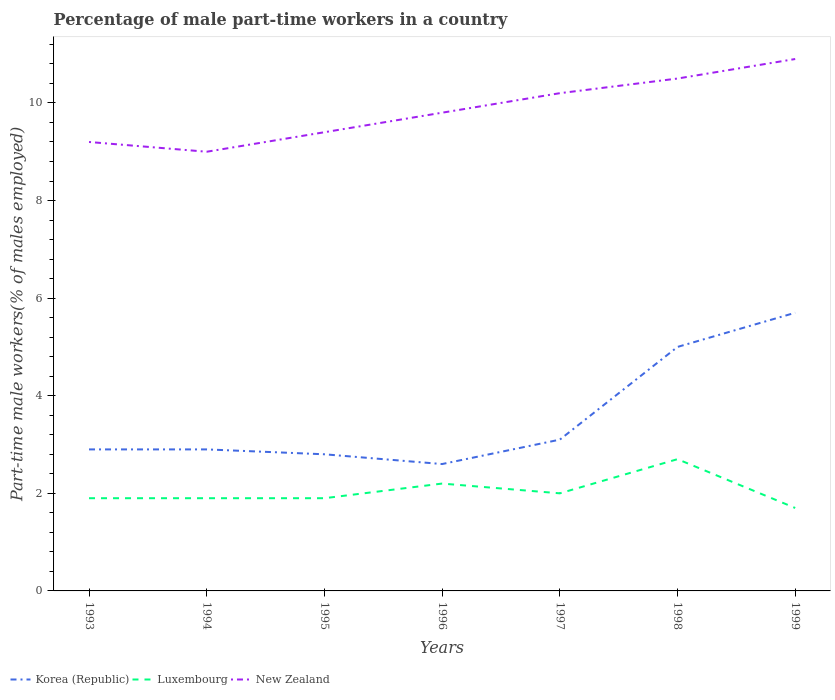Across all years, what is the maximum percentage of male part-time workers in Luxembourg?
Provide a short and direct response. 1.7. In which year was the percentage of male part-time workers in Luxembourg maximum?
Provide a succinct answer. 1999. What is the total percentage of male part-time workers in Luxembourg in the graph?
Offer a terse response. -0.3. What is the difference between the highest and the second highest percentage of male part-time workers in New Zealand?
Make the answer very short. 1.9. What is the difference between the highest and the lowest percentage of male part-time workers in Korea (Republic)?
Provide a short and direct response. 2. How many lines are there?
Provide a succinct answer. 3. How many years are there in the graph?
Give a very brief answer. 7. Are the values on the major ticks of Y-axis written in scientific E-notation?
Ensure brevity in your answer.  No. Does the graph contain any zero values?
Provide a succinct answer. No. Does the graph contain grids?
Offer a terse response. No. Where does the legend appear in the graph?
Your answer should be compact. Bottom left. How many legend labels are there?
Ensure brevity in your answer.  3. What is the title of the graph?
Keep it short and to the point. Percentage of male part-time workers in a country. Does "Guyana" appear as one of the legend labels in the graph?
Give a very brief answer. No. What is the label or title of the Y-axis?
Your response must be concise. Part-time male workers(% of males employed). What is the Part-time male workers(% of males employed) of Korea (Republic) in 1993?
Your answer should be compact. 2.9. What is the Part-time male workers(% of males employed) in Luxembourg in 1993?
Give a very brief answer. 1.9. What is the Part-time male workers(% of males employed) in New Zealand in 1993?
Provide a succinct answer. 9.2. What is the Part-time male workers(% of males employed) of Korea (Republic) in 1994?
Your response must be concise. 2.9. What is the Part-time male workers(% of males employed) in Luxembourg in 1994?
Offer a very short reply. 1.9. What is the Part-time male workers(% of males employed) in New Zealand in 1994?
Ensure brevity in your answer.  9. What is the Part-time male workers(% of males employed) in Korea (Republic) in 1995?
Provide a succinct answer. 2.8. What is the Part-time male workers(% of males employed) of Luxembourg in 1995?
Keep it short and to the point. 1.9. What is the Part-time male workers(% of males employed) of New Zealand in 1995?
Your answer should be very brief. 9.4. What is the Part-time male workers(% of males employed) in Korea (Republic) in 1996?
Your answer should be compact. 2.6. What is the Part-time male workers(% of males employed) in Luxembourg in 1996?
Keep it short and to the point. 2.2. What is the Part-time male workers(% of males employed) in New Zealand in 1996?
Provide a short and direct response. 9.8. What is the Part-time male workers(% of males employed) of Korea (Republic) in 1997?
Your response must be concise. 3.1. What is the Part-time male workers(% of males employed) in Luxembourg in 1997?
Make the answer very short. 2. What is the Part-time male workers(% of males employed) in New Zealand in 1997?
Make the answer very short. 10.2. What is the Part-time male workers(% of males employed) of Korea (Republic) in 1998?
Offer a very short reply. 5. What is the Part-time male workers(% of males employed) of Luxembourg in 1998?
Provide a succinct answer. 2.7. What is the Part-time male workers(% of males employed) in Korea (Republic) in 1999?
Your answer should be compact. 5.7. What is the Part-time male workers(% of males employed) of Luxembourg in 1999?
Keep it short and to the point. 1.7. What is the Part-time male workers(% of males employed) in New Zealand in 1999?
Make the answer very short. 10.9. Across all years, what is the maximum Part-time male workers(% of males employed) of Korea (Republic)?
Make the answer very short. 5.7. Across all years, what is the maximum Part-time male workers(% of males employed) in Luxembourg?
Offer a very short reply. 2.7. Across all years, what is the maximum Part-time male workers(% of males employed) in New Zealand?
Your answer should be compact. 10.9. Across all years, what is the minimum Part-time male workers(% of males employed) of Korea (Republic)?
Your answer should be very brief. 2.6. Across all years, what is the minimum Part-time male workers(% of males employed) of Luxembourg?
Provide a succinct answer. 1.7. Across all years, what is the minimum Part-time male workers(% of males employed) in New Zealand?
Give a very brief answer. 9. What is the total Part-time male workers(% of males employed) of Korea (Republic) in the graph?
Make the answer very short. 25. What is the total Part-time male workers(% of males employed) of New Zealand in the graph?
Offer a terse response. 69. What is the difference between the Part-time male workers(% of males employed) of Korea (Republic) in 1993 and that in 1994?
Your response must be concise. 0. What is the difference between the Part-time male workers(% of males employed) of Korea (Republic) in 1993 and that in 1995?
Give a very brief answer. 0.1. What is the difference between the Part-time male workers(% of males employed) in New Zealand in 1993 and that in 1995?
Keep it short and to the point. -0.2. What is the difference between the Part-time male workers(% of males employed) in Korea (Republic) in 1993 and that in 1996?
Provide a short and direct response. 0.3. What is the difference between the Part-time male workers(% of males employed) of New Zealand in 1993 and that in 1996?
Provide a succinct answer. -0.6. What is the difference between the Part-time male workers(% of males employed) in Korea (Republic) in 1993 and that in 1997?
Provide a short and direct response. -0.2. What is the difference between the Part-time male workers(% of males employed) of Luxembourg in 1993 and that in 1997?
Your answer should be compact. -0.1. What is the difference between the Part-time male workers(% of males employed) of New Zealand in 1993 and that in 1998?
Your answer should be very brief. -1.3. What is the difference between the Part-time male workers(% of males employed) in Korea (Republic) in 1993 and that in 1999?
Give a very brief answer. -2.8. What is the difference between the Part-time male workers(% of males employed) in Luxembourg in 1993 and that in 1999?
Give a very brief answer. 0.2. What is the difference between the Part-time male workers(% of males employed) of New Zealand in 1993 and that in 1999?
Give a very brief answer. -1.7. What is the difference between the Part-time male workers(% of males employed) in New Zealand in 1994 and that in 1995?
Make the answer very short. -0.4. What is the difference between the Part-time male workers(% of males employed) of Korea (Republic) in 1994 and that in 1996?
Provide a short and direct response. 0.3. What is the difference between the Part-time male workers(% of males employed) of Luxembourg in 1994 and that in 1996?
Your response must be concise. -0.3. What is the difference between the Part-time male workers(% of males employed) of New Zealand in 1994 and that in 1996?
Offer a terse response. -0.8. What is the difference between the Part-time male workers(% of males employed) of Korea (Republic) in 1994 and that in 1997?
Ensure brevity in your answer.  -0.2. What is the difference between the Part-time male workers(% of males employed) of Korea (Republic) in 1994 and that in 1998?
Your answer should be very brief. -2.1. What is the difference between the Part-time male workers(% of males employed) of New Zealand in 1994 and that in 1998?
Give a very brief answer. -1.5. What is the difference between the Part-time male workers(% of males employed) of Korea (Republic) in 1994 and that in 1999?
Your answer should be compact. -2.8. What is the difference between the Part-time male workers(% of males employed) of New Zealand in 1995 and that in 1996?
Offer a very short reply. -0.4. What is the difference between the Part-time male workers(% of males employed) in Luxembourg in 1995 and that in 1997?
Ensure brevity in your answer.  -0.1. What is the difference between the Part-time male workers(% of males employed) in Korea (Republic) in 1995 and that in 1998?
Give a very brief answer. -2.2. What is the difference between the Part-time male workers(% of males employed) in Luxembourg in 1995 and that in 1998?
Keep it short and to the point. -0.8. What is the difference between the Part-time male workers(% of males employed) of Korea (Republic) in 1995 and that in 1999?
Your answer should be compact. -2.9. What is the difference between the Part-time male workers(% of males employed) in New Zealand in 1996 and that in 1997?
Your response must be concise. -0.4. What is the difference between the Part-time male workers(% of males employed) in Korea (Republic) in 1996 and that in 1998?
Provide a short and direct response. -2.4. What is the difference between the Part-time male workers(% of males employed) of New Zealand in 1996 and that in 1998?
Your response must be concise. -0.7. What is the difference between the Part-time male workers(% of males employed) in Luxembourg in 1996 and that in 1999?
Provide a succinct answer. 0.5. What is the difference between the Part-time male workers(% of males employed) of Korea (Republic) in 1997 and that in 1998?
Your answer should be compact. -1.9. What is the difference between the Part-time male workers(% of males employed) of Luxembourg in 1997 and that in 1998?
Give a very brief answer. -0.7. What is the difference between the Part-time male workers(% of males employed) of New Zealand in 1997 and that in 1998?
Keep it short and to the point. -0.3. What is the difference between the Part-time male workers(% of males employed) in Luxembourg in 1997 and that in 1999?
Offer a terse response. 0.3. What is the difference between the Part-time male workers(% of males employed) of Korea (Republic) in 1998 and that in 1999?
Offer a very short reply. -0.7. What is the difference between the Part-time male workers(% of males employed) in Luxembourg in 1998 and that in 1999?
Provide a succinct answer. 1. What is the difference between the Part-time male workers(% of males employed) in Korea (Republic) in 1993 and the Part-time male workers(% of males employed) in New Zealand in 1994?
Your answer should be compact. -6.1. What is the difference between the Part-time male workers(% of males employed) of Korea (Republic) in 1993 and the Part-time male workers(% of males employed) of Luxembourg in 1996?
Your answer should be compact. 0.7. What is the difference between the Part-time male workers(% of males employed) in Luxembourg in 1993 and the Part-time male workers(% of males employed) in New Zealand in 1996?
Keep it short and to the point. -7.9. What is the difference between the Part-time male workers(% of males employed) in Luxembourg in 1993 and the Part-time male workers(% of males employed) in New Zealand in 1997?
Keep it short and to the point. -8.3. What is the difference between the Part-time male workers(% of males employed) of Korea (Republic) in 1993 and the Part-time male workers(% of males employed) of New Zealand in 1998?
Offer a very short reply. -7.6. What is the difference between the Part-time male workers(% of males employed) of Luxembourg in 1993 and the Part-time male workers(% of males employed) of New Zealand in 1998?
Your answer should be compact. -8.6. What is the difference between the Part-time male workers(% of males employed) in Korea (Republic) in 1993 and the Part-time male workers(% of males employed) in Luxembourg in 1999?
Your answer should be compact. 1.2. What is the difference between the Part-time male workers(% of males employed) in Korea (Republic) in 1993 and the Part-time male workers(% of males employed) in New Zealand in 1999?
Your response must be concise. -8. What is the difference between the Part-time male workers(% of males employed) in Luxembourg in 1993 and the Part-time male workers(% of males employed) in New Zealand in 1999?
Your answer should be compact. -9. What is the difference between the Part-time male workers(% of males employed) of Korea (Republic) in 1994 and the Part-time male workers(% of males employed) of New Zealand in 1995?
Provide a short and direct response. -6.5. What is the difference between the Part-time male workers(% of males employed) in Luxembourg in 1994 and the Part-time male workers(% of males employed) in New Zealand in 1995?
Make the answer very short. -7.5. What is the difference between the Part-time male workers(% of males employed) of Korea (Republic) in 1994 and the Part-time male workers(% of males employed) of Luxembourg in 1996?
Your answer should be compact. 0.7. What is the difference between the Part-time male workers(% of males employed) in Korea (Republic) in 1994 and the Part-time male workers(% of males employed) in New Zealand in 1996?
Give a very brief answer. -6.9. What is the difference between the Part-time male workers(% of males employed) in Luxembourg in 1994 and the Part-time male workers(% of males employed) in New Zealand in 1996?
Provide a succinct answer. -7.9. What is the difference between the Part-time male workers(% of males employed) of Luxembourg in 1994 and the Part-time male workers(% of males employed) of New Zealand in 1997?
Make the answer very short. -8.3. What is the difference between the Part-time male workers(% of males employed) in Korea (Republic) in 1994 and the Part-time male workers(% of males employed) in Luxembourg in 1998?
Your answer should be very brief. 0.2. What is the difference between the Part-time male workers(% of males employed) in Korea (Republic) in 1994 and the Part-time male workers(% of males employed) in New Zealand in 1999?
Give a very brief answer. -8. What is the difference between the Part-time male workers(% of males employed) in Luxembourg in 1994 and the Part-time male workers(% of males employed) in New Zealand in 1999?
Your response must be concise. -9. What is the difference between the Part-time male workers(% of males employed) in Korea (Republic) in 1995 and the Part-time male workers(% of males employed) in Luxembourg in 1996?
Ensure brevity in your answer.  0.6. What is the difference between the Part-time male workers(% of males employed) of Korea (Republic) in 1995 and the Part-time male workers(% of males employed) of New Zealand in 1996?
Your response must be concise. -7. What is the difference between the Part-time male workers(% of males employed) in Korea (Republic) in 1995 and the Part-time male workers(% of males employed) in Luxembourg in 1997?
Provide a short and direct response. 0.8. What is the difference between the Part-time male workers(% of males employed) in Korea (Republic) in 1995 and the Part-time male workers(% of males employed) in New Zealand in 1997?
Your answer should be compact. -7.4. What is the difference between the Part-time male workers(% of males employed) in Luxembourg in 1995 and the Part-time male workers(% of males employed) in New Zealand in 1997?
Your answer should be very brief. -8.3. What is the difference between the Part-time male workers(% of males employed) of Korea (Republic) in 1995 and the Part-time male workers(% of males employed) of New Zealand in 1999?
Provide a short and direct response. -8.1. What is the difference between the Part-time male workers(% of males employed) in Luxembourg in 1995 and the Part-time male workers(% of males employed) in New Zealand in 1999?
Give a very brief answer. -9. What is the difference between the Part-time male workers(% of males employed) of Luxembourg in 1996 and the Part-time male workers(% of males employed) of New Zealand in 1997?
Offer a very short reply. -8. What is the difference between the Part-time male workers(% of males employed) of Korea (Republic) in 1996 and the Part-time male workers(% of males employed) of Luxembourg in 1999?
Your response must be concise. 0.9. What is the difference between the Part-time male workers(% of males employed) in Korea (Republic) in 1996 and the Part-time male workers(% of males employed) in New Zealand in 1999?
Offer a very short reply. -8.3. What is the difference between the Part-time male workers(% of males employed) in Luxembourg in 1996 and the Part-time male workers(% of males employed) in New Zealand in 1999?
Give a very brief answer. -8.7. What is the difference between the Part-time male workers(% of males employed) in Korea (Republic) in 1997 and the Part-time male workers(% of males employed) in New Zealand in 1998?
Make the answer very short. -7.4. What is the difference between the Part-time male workers(% of males employed) of Korea (Republic) in 1997 and the Part-time male workers(% of males employed) of Luxembourg in 1999?
Make the answer very short. 1.4. What is the difference between the Part-time male workers(% of males employed) in Korea (Republic) in 1997 and the Part-time male workers(% of males employed) in New Zealand in 1999?
Ensure brevity in your answer.  -7.8. What is the difference between the Part-time male workers(% of males employed) of Korea (Republic) in 1998 and the Part-time male workers(% of males employed) of New Zealand in 1999?
Offer a very short reply. -5.9. What is the average Part-time male workers(% of males employed) of Korea (Republic) per year?
Ensure brevity in your answer.  3.57. What is the average Part-time male workers(% of males employed) of Luxembourg per year?
Keep it short and to the point. 2.04. What is the average Part-time male workers(% of males employed) of New Zealand per year?
Offer a terse response. 9.86. In the year 1993, what is the difference between the Part-time male workers(% of males employed) of Luxembourg and Part-time male workers(% of males employed) of New Zealand?
Provide a short and direct response. -7.3. In the year 1994, what is the difference between the Part-time male workers(% of males employed) in Luxembourg and Part-time male workers(% of males employed) in New Zealand?
Provide a succinct answer. -7.1. In the year 1995, what is the difference between the Part-time male workers(% of males employed) of Korea (Republic) and Part-time male workers(% of males employed) of New Zealand?
Give a very brief answer. -6.6. In the year 1995, what is the difference between the Part-time male workers(% of males employed) in Luxembourg and Part-time male workers(% of males employed) in New Zealand?
Provide a short and direct response. -7.5. In the year 1996, what is the difference between the Part-time male workers(% of males employed) of Korea (Republic) and Part-time male workers(% of males employed) of New Zealand?
Provide a short and direct response. -7.2. In the year 1997, what is the difference between the Part-time male workers(% of males employed) of Korea (Republic) and Part-time male workers(% of males employed) of Luxembourg?
Make the answer very short. 1.1. In the year 1998, what is the difference between the Part-time male workers(% of males employed) of Korea (Republic) and Part-time male workers(% of males employed) of Luxembourg?
Give a very brief answer. 2.3. In the year 1998, what is the difference between the Part-time male workers(% of males employed) in Korea (Republic) and Part-time male workers(% of males employed) in New Zealand?
Give a very brief answer. -5.5. In the year 1999, what is the difference between the Part-time male workers(% of males employed) of Korea (Republic) and Part-time male workers(% of males employed) of New Zealand?
Offer a terse response. -5.2. In the year 1999, what is the difference between the Part-time male workers(% of males employed) in Luxembourg and Part-time male workers(% of males employed) in New Zealand?
Make the answer very short. -9.2. What is the ratio of the Part-time male workers(% of males employed) of Korea (Republic) in 1993 to that in 1994?
Ensure brevity in your answer.  1. What is the ratio of the Part-time male workers(% of males employed) of Luxembourg in 1993 to that in 1994?
Make the answer very short. 1. What is the ratio of the Part-time male workers(% of males employed) of New Zealand in 1993 to that in 1994?
Offer a terse response. 1.02. What is the ratio of the Part-time male workers(% of males employed) of Korea (Republic) in 1993 to that in 1995?
Provide a succinct answer. 1.04. What is the ratio of the Part-time male workers(% of males employed) of New Zealand in 1993 to that in 1995?
Give a very brief answer. 0.98. What is the ratio of the Part-time male workers(% of males employed) of Korea (Republic) in 1993 to that in 1996?
Your answer should be very brief. 1.12. What is the ratio of the Part-time male workers(% of males employed) in Luxembourg in 1993 to that in 1996?
Your response must be concise. 0.86. What is the ratio of the Part-time male workers(% of males employed) of New Zealand in 1993 to that in 1996?
Offer a very short reply. 0.94. What is the ratio of the Part-time male workers(% of males employed) in Korea (Republic) in 1993 to that in 1997?
Offer a terse response. 0.94. What is the ratio of the Part-time male workers(% of males employed) in New Zealand in 1993 to that in 1997?
Your response must be concise. 0.9. What is the ratio of the Part-time male workers(% of males employed) in Korea (Republic) in 1993 to that in 1998?
Offer a terse response. 0.58. What is the ratio of the Part-time male workers(% of males employed) in Luxembourg in 1993 to that in 1998?
Give a very brief answer. 0.7. What is the ratio of the Part-time male workers(% of males employed) of New Zealand in 1993 to that in 1998?
Provide a succinct answer. 0.88. What is the ratio of the Part-time male workers(% of males employed) of Korea (Republic) in 1993 to that in 1999?
Offer a very short reply. 0.51. What is the ratio of the Part-time male workers(% of males employed) of Luxembourg in 1993 to that in 1999?
Your response must be concise. 1.12. What is the ratio of the Part-time male workers(% of males employed) of New Zealand in 1993 to that in 1999?
Give a very brief answer. 0.84. What is the ratio of the Part-time male workers(% of males employed) of Korea (Republic) in 1994 to that in 1995?
Give a very brief answer. 1.04. What is the ratio of the Part-time male workers(% of males employed) in New Zealand in 1994 to that in 1995?
Make the answer very short. 0.96. What is the ratio of the Part-time male workers(% of males employed) in Korea (Republic) in 1994 to that in 1996?
Provide a succinct answer. 1.12. What is the ratio of the Part-time male workers(% of males employed) of Luxembourg in 1994 to that in 1996?
Give a very brief answer. 0.86. What is the ratio of the Part-time male workers(% of males employed) of New Zealand in 1994 to that in 1996?
Your answer should be compact. 0.92. What is the ratio of the Part-time male workers(% of males employed) of Korea (Republic) in 1994 to that in 1997?
Provide a succinct answer. 0.94. What is the ratio of the Part-time male workers(% of males employed) in New Zealand in 1994 to that in 1997?
Your answer should be compact. 0.88. What is the ratio of the Part-time male workers(% of males employed) in Korea (Republic) in 1994 to that in 1998?
Ensure brevity in your answer.  0.58. What is the ratio of the Part-time male workers(% of males employed) in Luxembourg in 1994 to that in 1998?
Give a very brief answer. 0.7. What is the ratio of the Part-time male workers(% of males employed) in Korea (Republic) in 1994 to that in 1999?
Provide a succinct answer. 0.51. What is the ratio of the Part-time male workers(% of males employed) of Luxembourg in 1994 to that in 1999?
Make the answer very short. 1.12. What is the ratio of the Part-time male workers(% of males employed) in New Zealand in 1994 to that in 1999?
Make the answer very short. 0.83. What is the ratio of the Part-time male workers(% of males employed) in Luxembourg in 1995 to that in 1996?
Provide a succinct answer. 0.86. What is the ratio of the Part-time male workers(% of males employed) of New Zealand in 1995 to that in 1996?
Offer a very short reply. 0.96. What is the ratio of the Part-time male workers(% of males employed) of Korea (Republic) in 1995 to that in 1997?
Provide a short and direct response. 0.9. What is the ratio of the Part-time male workers(% of males employed) of Luxembourg in 1995 to that in 1997?
Your response must be concise. 0.95. What is the ratio of the Part-time male workers(% of males employed) of New Zealand in 1995 to that in 1997?
Your answer should be very brief. 0.92. What is the ratio of the Part-time male workers(% of males employed) of Korea (Republic) in 1995 to that in 1998?
Offer a terse response. 0.56. What is the ratio of the Part-time male workers(% of males employed) in Luxembourg in 1995 to that in 1998?
Offer a very short reply. 0.7. What is the ratio of the Part-time male workers(% of males employed) in New Zealand in 1995 to that in 1998?
Make the answer very short. 0.9. What is the ratio of the Part-time male workers(% of males employed) of Korea (Republic) in 1995 to that in 1999?
Keep it short and to the point. 0.49. What is the ratio of the Part-time male workers(% of males employed) in Luxembourg in 1995 to that in 1999?
Offer a terse response. 1.12. What is the ratio of the Part-time male workers(% of males employed) of New Zealand in 1995 to that in 1999?
Offer a very short reply. 0.86. What is the ratio of the Part-time male workers(% of males employed) in Korea (Republic) in 1996 to that in 1997?
Ensure brevity in your answer.  0.84. What is the ratio of the Part-time male workers(% of males employed) of New Zealand in 1996 to that in 1997?
Make the answer very short. 0.96. What is the ratio of the Part-time male workers(% of males employed) of Korea (Republic) in 1996 to that in 1998?
Offer a terse response. 0.52. What is the ratio of the Part-time male workers(% of males employed) of Luxembourg in 1996 to that in 1998?
Make the answer very short. 0.81. What is the ratio of the Part-time male workers(% of males employed) in Korea (Republic) in 1996 to that in 1999?
Provide a succinct answer. 0.46. What is the ratio of the Part-time male workers(% of males employed) in Luxembourg in 1996 to that in 1999?
Provide a succinct answer. 1.29. What is the ratio of the Part-time male workers(% of males employed) in New Zealand in 1996 to that in 1999?
Provide a short and direct response. 0.9. What is the ratio of the Part-time male workers(% of males employed) in Korea (Republic) in 1997 to that in 1998?
Offer a terse response. 0.62. What is the ratio of the Part-time male workers(% of males employed) in Luxembourg in 1997 to that in 1998?
Your answer should be very brief. 0.74. What is the ratio of the Part-time male workers(% of males employed) in New Zealand in 1997 to that in 1998?
Your answer should be very brief. 0.97. What is the ratio of the Part-time male workers(% of males employed) in Korea (Republic) in 1997 to that in 1999?
Ensure brevity in your answer.  0.54. What is the ratio of the Part-time male workers(% of males employed) of Luxembourg in 1997 to that in 1999?
Your answer should be compact. 1.18. What is the ratio of the Part-time male workers(% of males employed) in New Zealand in 1997 to that in 1999?
Your answer should be very brief. 0.94. What is the ratio of the Part-time male workers(% of males employed) in Korea (Republic) in 1998 to that in 1999?
Give a very brief answer. 0.88. What is the ratio of the Part-time male workers(% of males employed) of Luxembourg in 1998 to that in 1999?
Provide a short and direct response. 1.59. What is the ratio of the Part-time male workers(% of males employed) in New Zealand in 1998 to that in 1999?
Your response must be concise. 0.96. What is the difference between the highest and the second highest Part-time male workers(% of males employed) in Luxembourg?
Your answer should be very brief. 0.5. What is the difference between the highest and the second highest Part-time male workers(% of males employed) of New Zealand?
Your answer should be compact. 0.4. 